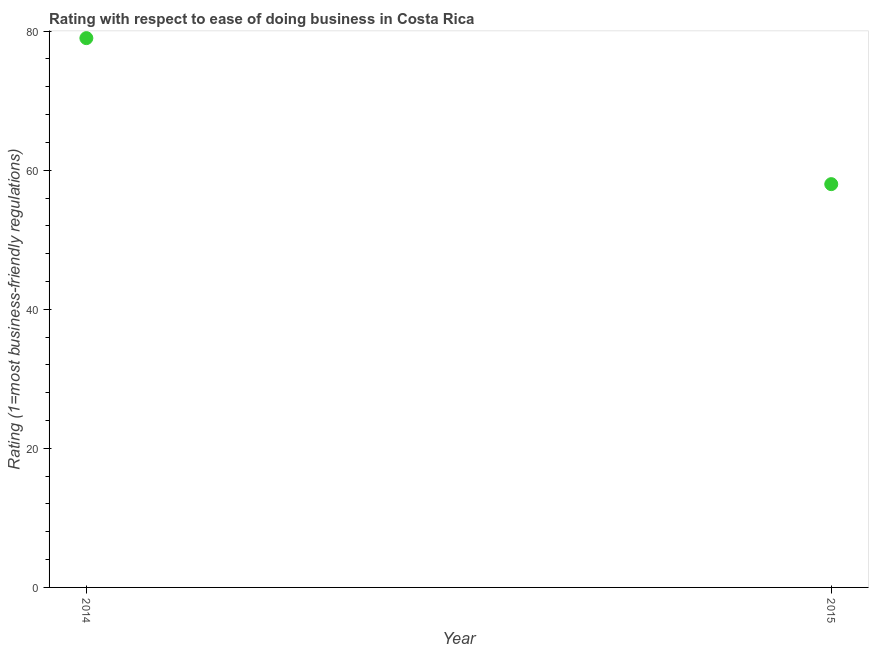What is the ease of doing business index in 2015?
Provide a short and direct response. 58. Across all years, what is the maximum ease of doing business index?
Offer a very short reply. 79. Across all years, what is the minimum ease of doing business index?
Your answer should be very brief. 58. In which year was the ease of doing business index minimum?
Your answer should be very brief. 2015. What is the sum of the ease of doing business index?
Keep it short and to the point. 137. What is the difference between the ease of doing business index in 2014 and 2015?
Offer a very short reply. 21. What is the average ease of doing business index per year?
Offer a terse response. 68.5. What is the median ease of doing business index?
Offer a very short reply. 68.5. Do a majority of the years between 2015 and 2014 (inclusive) have ease of doing business index greater than 68 ?
Ensure brevity in your answer.  No. What is the ratio of the ease of doing business index in 2014 to that in 2015?
Offer a very short reply. 1.36. How many dotlines are there?
Keep it short and to the point. 1. How many years are there in the graph?
Offer a terse response. 2. Are the values on the major ticks of Y-axis written in scientific E-notation?
Make the answer very short. No. What is the title of the graph?
Offer a terse response. Rating with respect to ease of doing business in Costa Rica. What is the label or title of the Y-axis?
Keep it short and to the point. Rating (1=most business-friendly regulations). What is the Rating (1=most business-friendly regulations) in 2014?
Your response must be concise. 79. What is the difference between the Rating (1=most business-friendly regulations) in 2014 and 2015?
Your answer should be very brief. 21. What is the ratio of the Rating (1=most business-friendly regulations) in 2014 to that in 2015?
Offer a terse response. 1.36. 